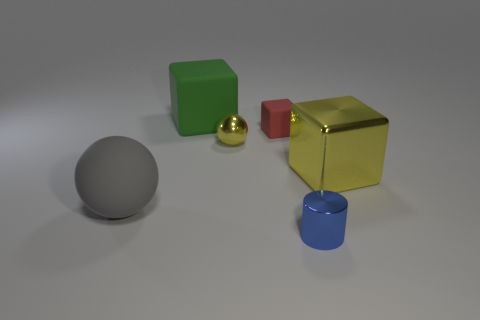There is a tiny metallic cylinder; is it the same color as the small object that is behind the metallic ball?
Offer a very short reply. No. How many big objects are there?
Provide a succinct answer. 3. Is there another rubber ball of the same color as the large ball?
Offer a terse response. No. There is a large cube to the left of the big object that is on the right side of the yellow thing that is on the left side of the cylinder; what color is it?
Provide a short and direct response. Green. Is the material of the blue cylinder the same as the big cube that is on the left side of the big yellow block?
Keep it short and to the point. No. What material is the small yellow object?
Your response must be concise. Metal. What material is the large cube that is the same color as the small ball?
Your answer should be compact. Metal. How many other objects are the same material as the large green cube?
Ensure brevity in your answer.  2. There is a big thing that is in front of the small yellow shiny object and to the left of the large yellow object; what is its shape?
Your answer should be compact. Sphere. What is the color of the large thing that is the same material as the tiny sphere?
Ensure brevity in your answer.  Yellow. 